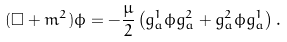Convert formula to latex. <formula><loc_0><loc_0><loc_500><loc_500>( \Box + m ^ { 2 } ) \phi = - \frac { \mu } { 2 } \left ( g ^ { 1 } _ { a } \phi g ^ { 2 } _ { a } + g ^ { 2 } _ { a } \phi g ^ { 1 } _ { a } \right ) .</formula> 